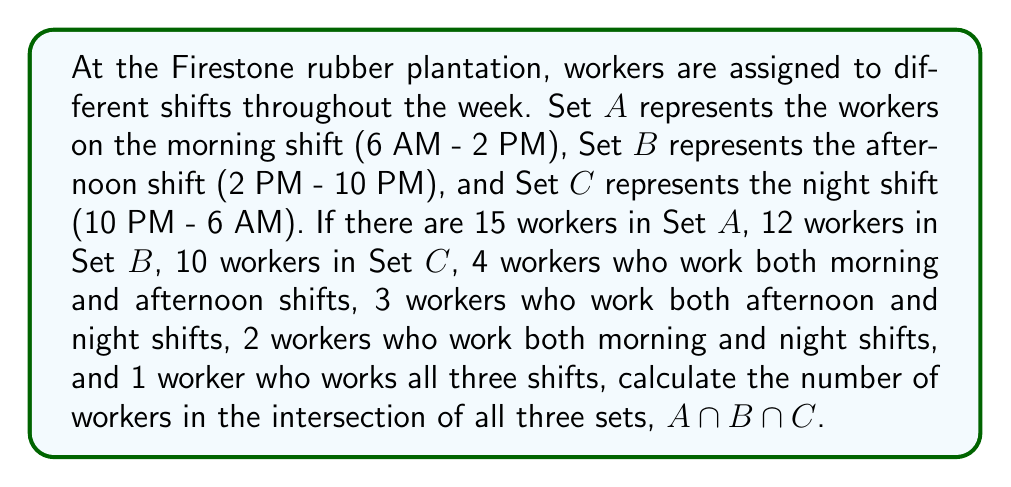Can you solve this math problem? To solve this problem, we'll use the principle of inclusion-exclusion for three sets. The formula for the intersection of three sets is:

$$|A \cap B \cap C| = |A| + |B| + |C| - |A \cup B| - |A \cup C| - |B \cup C| + |A \cup B \cup C|$$

We're given:
$|A| = 15$, $|B| = 12$, $|C| = 10$
$|A \cap B| = 4$, $|B \cap C| = 3$, $|A \cap C| = 2$
$|A \cap B \cap C| = 1$ (the worker who works all three shifts)

To find $|A \cup B|$, $|A \cup C|$, and $|B \cup C|$, we use the formula:
$|X \cup Y| = |X| + |Y| - |X \cap Y|$

$|A \cup B| = 15 + 12 - 4 = 23$
$|A \cup C| = 15 + 10 - 2 = 23$
$|B \cup C| = 12 + 10 - 3 = 19$

To find $|A \cup B \cup C|$, we use the inclusion-exclusion principle:
$|A \cup B \cup C| = |A| + |B| + |C| - |A \cap B| - |A \cap C| - |B \cap C| + |A \cap B \cap C|$
$|A \cup B \cup C| = 15 + 12 + 10 - 4 - 2 - 3 + 1 = 29$

Now we can plug these values into the original formula:

$$|A \cap B \cap C| = 15 + 12 + 10 - 23 - 23 - 19 + 29 = 1$$

This confirms the given information that there is 1 worker who works all three shifts.
Answer: $|A \cap B \cap C| = 1$ 